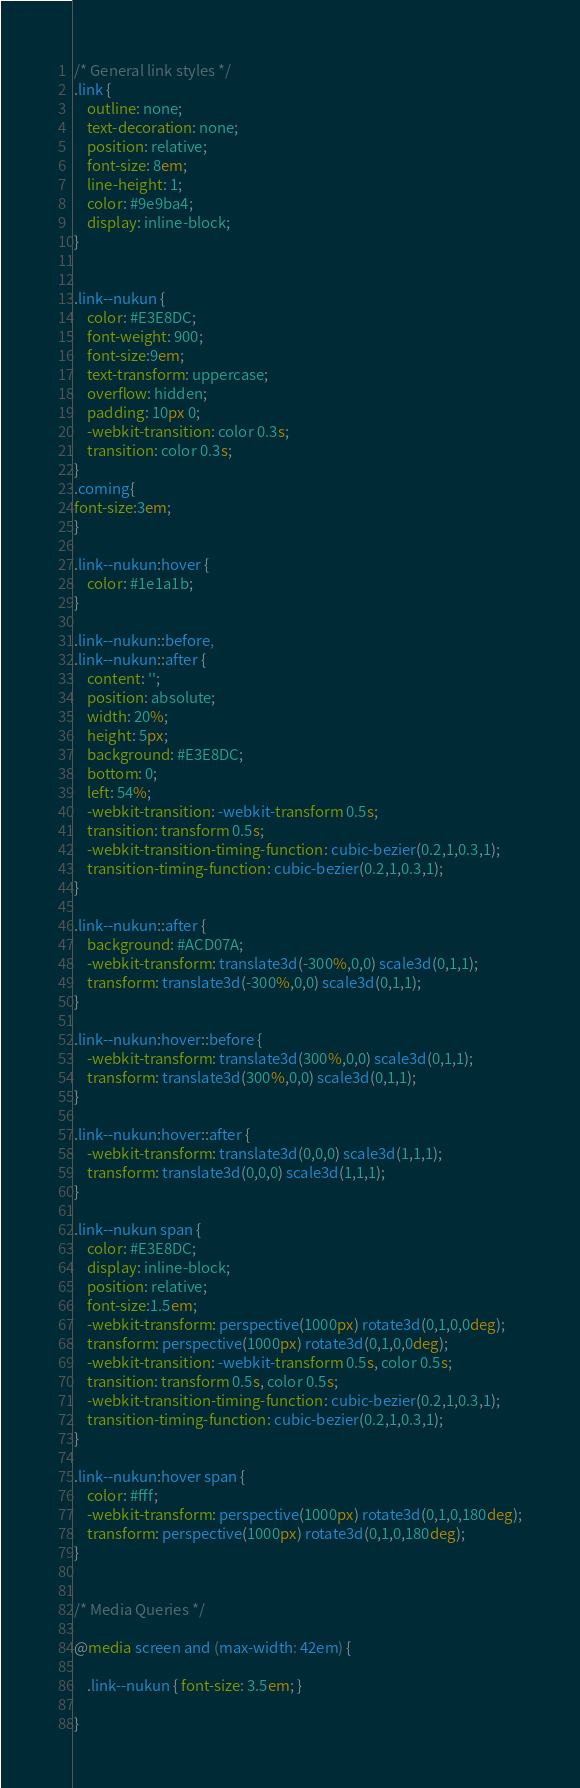<code> <loc_0><loc_0><loc_500><loc_500><_CSS_>/* General link styles */
.link {
	outline: none;
	text-decoration: none;
	position: relative;
	font-size: 8em;
	line-height: 1;
	color: #9e9ba4;
	display: inline-block;
}


.link--nukun {
	color: #E3E8DC;
	font-weight: 900;
	font-size:9em;
	text-transform: uppercase;
	overflow: hidden;
	padding: 10px 0;
	-webkit-transition: color 0.3s;
	transition: color 0.3s;
}
.coming{
font-size:3em;
}

.link--nukun:hover {
	color: #1e1a1b;
}

.link--nukun::before,
.link--nukun::after {
	content: '';
	position: absolute;
	width: 20%;
	height: 5px;
	background: #E3E8DC;
	bottom: 0;
	left: 54%;
	-webkit-transition: -webkit-transform 0.5s;
	transition: transform 0.5s;
	-webkit-transition-timing-function: cubic-bezier(0.2,1,0.3,1);
	transition-timing-function: cubic-bezier(0.2,1,0.3,1);
}

.link--nukun::after {
	background: #ACD07A;
	-webkit-transform: translate3d(-300%,0,0) scale3d(0,1,1);
	transform: translate3d(-300%,0,0) scale3d(0,1,1);
}

.link--nukun:hover::before {
	-webkit-transform: translate3d(300%,0,0) scale3d(0,1,1);
	transform: translate3d(300%,0,0) scale3d(0,1,1);
}

.link--nukun:hover::after {
	-webkit-transform: translate3d(0,0,0) scale3d(1,1,1);
	transform: translate3d(0,0,0) scale3d(1,1,1);
}

.link--nukun span {
	color: #E3E8DC;
	display: inline-block;
	position: relative;
	font-size:1.5em;
	-webkit-transform: perspective(1000px) rotate3d(0,1,0,0deg);
	transform: perspective(1000px) rotate3d(0,1,0,0deg);
	-webkit-transition: -webkit-transform 0.5s, color 0.5s;
	transition: transform 0.5s, color 0.5s;
	-webkit-transition-timing-function: cubic-bezier(0.2,1,0.3,1);
	transition-timing-function: cubic-bezier(0.2,1,0.3,1);
}

.link--nukun:hover span {
	color: #fff;
	-webkit-transform: perspective(1000px) rotate3d(0,1,0,180deg);
	transform: perspective(1000px) rotate3d(0,1,0,180deg);
}


/* Media Queries */

@media screen and (max-width: 42em) {

	.link--nukun { font-size: 3.5em; }
	
}
</code> 